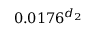<formula> <loc_0><loc_0><loc_500><loc_500>0 . 0 1 7 6 ^ { d _ { 2 } }</formula> 